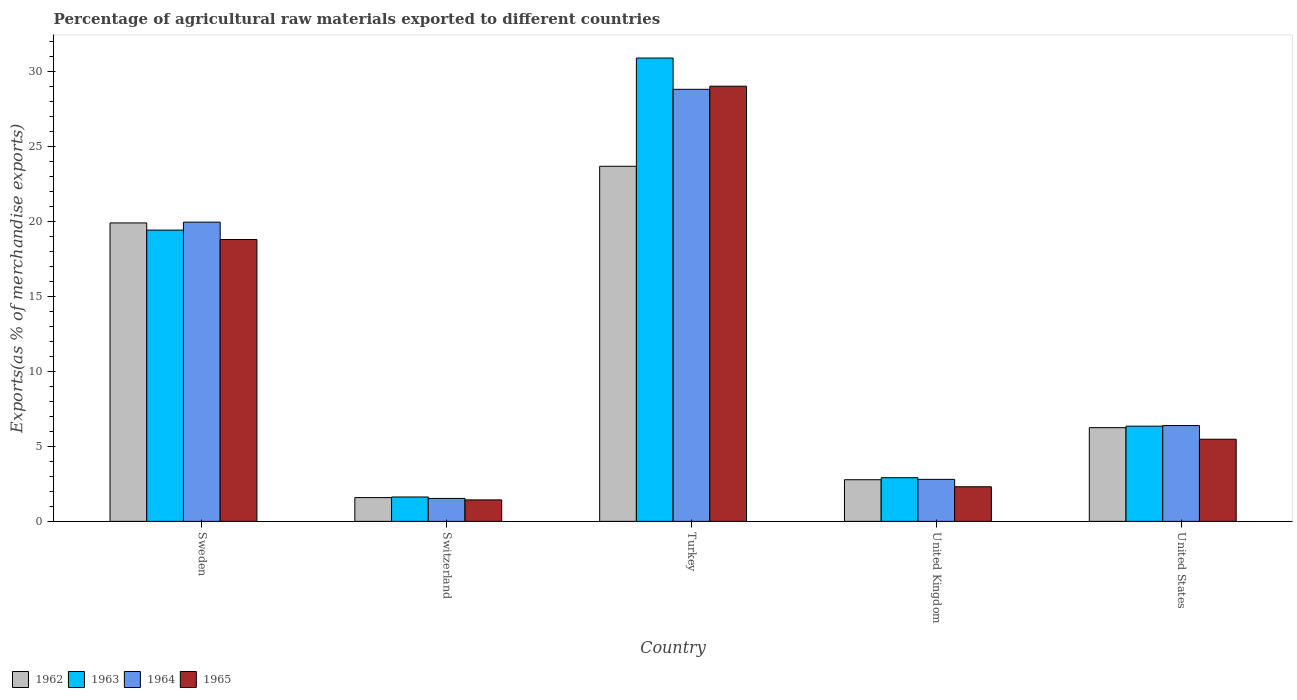How many groups of bars are there?
Provide a short and direct response. 5. Are the number of bars on each tick of the X-axis equal?
Keep it short and to the point. Yes. How many bars are there on the 2nd tick from the left?
Give a very brief answer. 4. How many bars are there on the 3rd tick from the right?
Your response must be concise. 4. In how many cases, is the number of bars for a given country not equal to the number of legend labels?
Give a very brief answer. 0. What is the percentage of exports to different countries in 1963 in United Kingdom?
Keep it short and to the point. 2.91. Across all countries, what is the maximum percentage of exports to different countries in 1964?
Your answer should be very brief. 28.78. Across all countries, what is the minimum percentage of exports to different countries in 1964?
Keep it short and to the point. 1.53. In which country was the percentage of exports to different countries in 1963 maximum?
Your response must be concise. Turkey. In which country was the percentage of exports to different countries in 1962 minimum?
Your answer should be very brief. Switzerland. What is the total percentage of exports to different countries in 1963 in the graph?
Your answer should be very brief. 61.14. What is the difference between the percentage of exports to different countries in 1965 in Sweden and that in Switzerland?
Offer a terse response. 17.35. What is the difference between the percentage of exports to different countries in 1964 in Sweden and the percentage of exports to different countries in 1965 in Turkey?
Offer a very short reply. -9.06. What is the average percentage of exports to different countries in 1962 per country?
Your answer should be very brief. 10.83. What is the difference between the percentage of exports to different countries of/in 1963 and percentage of exports to different countries of/in 1964 in Switzerland?
Your answer should be very brief. 0.1. What is the ratio of the percentage of exports to different countries in 1965 in United Kingdom to that in United States?
Your answer should be compact. 0.42. Is the percentage of exports to different countries in 1964 in Sweden less than that in Switzerland?
Make the answer very short. No. What is the difference between the highest and the second highest percentage of exports to different countries in 1962?
Ensure brevity in your answer.  13.64. What is the difference between the highest and the lowest percentage of exports to different countries in 1964?
Provide a short and direct response. 27.25. Is the sum of the percentage of exports to different countries in 1965 in Turkey and United Kingdom greater than the maximum percentage of exports to different countries in 1962 across all countries?
Give a very brief answer. Yes. What does the 4th bar from the left in United States represents?
Make the answer very short. 1965. Are all the bars in the graph horizontal?
Your response must be concise. No. What is the difference between two consecutive major ticks on the Y-axis?
Provide a short and direct response. 5. Are the values on the major ticks of Y-axis written in scientific E-notation?
Make the answer very short. No. Does the graph contain grids?
Give a very brief answer. No. Where does the legend appear in the graph?
Make the answer very short. Bottom left. What is the title of the graph?
Your answer should be very brief. Percentage of agricultural raw materials exported to different countries. Does "2014" appear as one of the legend labels in the graph?
Keep it short and to the point. No. What is the label or title of the Y-axis?
Give a very brief answer. Exports(as % of merchandise exports). What is the Exports(as % of merchandise exports) in 1962 in Sweden?
Give a very brief answer. 19.88. What is the Exports(as % of merchandise exports) in 1963 in Sweden?
Give a very brief answer. 19.4. What is the Exports(as % of merchandise exports) of 1964 in Sweden?
Your answer should be compact. 19.93. What is the Exports(as % of merchandise exports) of 1965 in Sweden?
Your answer should be compact. 18.78. What is the Exports(as % of merchandise exports) of 1962 in Switzerland?
Ensure brevity in your answer.  1.58. What is the Exports(as % of merchandise exports) in 1963 in Switzerland?
Ensure brevity in your answer.  1.62. What is the Exports(as % of merchandise exports) in 1964 in Switzerland?
Make the answer very short. 1.53. What is the Exports(as % of merchandise exports) in 1965 in Switzerland?
Keep it short and to the point. 1.43. What is the Exports(as % of merchandise exports) of 1962 in Turkey?
Give a very brief answer. 23.65. What is the Exports(as % of merchandise exports) in 1963 in Turkey?
Your answer should be very brief. 30.86. What is the Exports(as % of merchandise exports) of 1964 in Turkey?
Your answer should be compact. 28.78. What is the Exports(as % of merchandise exports) in 1965 in Turkey?
Your response must be concise. 28.99. What is the Exports(as % of merchandise exports) of 1962 in United Kingdom?
Your answer should be compact. 2.77. What is the Exports(as % of merchandise exports) in 1963 in United Kingdom?
Your answer should be compact. 2.91. What is the Exports(as % of merchandise exports) of 1964 in United Kingdom?
Your answer should be very brief. 2.8. What is the Exports(as % of merchandise exports) of 1965 in United Kingdom?
Provide a succinct answer. 2.3. What is the Exports(as % of merchandise exports) in 1962 in United States?
Keep it short and to the point. 6.24. What is the Exports(as % of merchandise exports) in 1963 in United States?
Your answer should be compact. 6.34. What is the Exports(as % of merchandise exports) in 1964 in United States?
Provide a short and direct response. 6.38. What is the Exports(as % of merchandise exports) in 1965 in United States?
Provide a succinct answer. 5.47. Across all countries, what is the maximum Exports(as % of merchandise exports) in 1962?
Make the answer very short. 23.65. Across all countries, what is the maximum Exports(as % of merchandise exports) of 1963?
Keep it short and to the point. 30.86. Across all countries, what is the maximum Exports(as % of merchandise exports) in 1964?
Provide a succinct answer. 28.78. Across all countries, what is the maximum Exports(as % of merchandise exports) in 1965?
Offer a very short reply. 28.99. Across all countries, what is the minimum Exports(as % of merchandise exports) of 1962?
Your response must be concise. 1.58. Across all countries, what is the minimum Exports(as % of merchandise exports) in 1963?
Keep it short and to the point. 1.62. Across all countries, what is the minimum Exports(as % of merchandise exports) of 1964?
Keep it short and to the point. 1.53. Across all countries, what is the minimum Exports(as % of merchandise exports) of 1965?
Ensure brevity in your answer.  1.43. What is the total Exports(as % of merchandise exports) in 1962 in the graph?
Provide a succinct answer. 54.14. What is the total Exports(as % of merchandise exports) in 1963 in the graph?
Give a very brief answer. 61.14. What is the total Exports(as % of merchandise exports) of 1964 in the graph?
Offer a very short reply. 59.42. What is the total Exports(as % of merchandise exports) in 1965 in the graph?
Provide a succinct answer. 56.97. What is the difference between the Exports(as % of merchandise exports) of 1962 in Sweden and that in Switzerland?
Offer a terse response. 18.3. What is the difference between the Exports(as % of merchandise exports) of 1963 in Sweden and that in Switzerland?
Give a very brief answer. 17.78. What is the difference between the Exports(as % of merchandise exports) in 1964 in Sweden and that in Switzerland?
Offer a very short reply. 18.4. What is the difference between the Exports(as % of merchandise exports) of 1965 in Sweden and that in Switzerland?
Make the answer very short. 17.35. What is the difference between the Exports(as % of merchandise exports) of 1962 in Sweden and that in Turkey?
Your answer should be very brief. -3.77. What is the difference between the Exports(as % of merchandise exports) of 1963 in Sweden and that in Turkey?
Provide a succinct answer. -11.46. What is the difference between the Exports(as % of merchandise exports) of 1964 in Sweden and that in Turkey?
Provide a succinct answer. -8.85. What is the difference between the Exports(as % of merchandise exports) in 1965 in Sweden and that in Turkey?
Make the answer very short. -10.21. What is the difference between the Exports(as % of merchandise exports) in 1962 in Sweden and that in United Kingdom?
Your response must be concise. 17.11. What is the difference between the Exports(as % of merchandise exports) in 1963 in Sweden and that in United Kingdom?
Ensure brevity in your answer.  16.49. What is the difference between the Exports(as % of merchandise exports) of 1964 in Sweden and that in United Kingdom?
Give a very brief answer. 17.13. What is the difference between the Exports(as % of merchandise exports) in 1965 in Sweden and that in United Kingdom?
Provide a short and direct response. 16.47. What is the difference between the Exports(as % of merchandise exports) of 1962 in Sweden and that in United States?
Provide a short and direct response. 13.64. What is the difference between the Exports(as % of merchandise exports) in 1963 in Sweden and that in United States?
Provide a short and direct response. 13.06. What is the difference between the Exports(as % of merchandise exports) in 1964 in Sweden and that in United States?
Your answer should be compact. 13.55. What is the difference between the Exports(as % of merchandise exports) of 1965 in Sweden and that in United States?
Offer a very short reply. 13.3. What is the difference between the Exports(as % of merchandise exports) of 1962 in Switzerland and that in Turkey?
Offer a terse response. -22.07. What is the difference between the Exports(as % of merchandise exports) of 1963 in Switzerland and that in Turkey?
Keep it short and to the point. -29.24. What is the difference between the Exports(as % of merchandise exports) of 1964 in Switzerland and that in Turkey?
Provide a succinct answer. -27.25. What is the difference between the Exports(as % of merchandise exports) in 1965 in Switzerland and that in Turkey?
Your answer should be compact. -27.56. What is the difference between the Exports(as % of merchandise exports) in 1962 in Switzerland and that in United Kingdom?
Provide a short and direct response. -1.19. What is the difference between the Exports(as % of merchandise exports) in 1963 in Switzerland and that in United Kingdom?
Offer a very short reply. -1.28. What is the difference between the Exports(as % of merchandise exports) of 1964 in Switzerland and that in United Kingdom?
Your answer should be very brief. -1.27. What is the difference between the Exports(as % of merchandise exports) in 1965 in Switzerland and that in United Kingdom?
Offer a very short reply. -0.87. What is the difference between the Exports(as % of merchandise exports) of 1962 in Switzerland and that in United States?
Ensure brevity in your answer.  -4.66. What is the difference between the Exports(as % of merchandise exports) in 1963 in Switzerland and that in United States?
Provide a succinct answer. -4.72. What is the difference between the Exports(as % of merchandise exports) in 1964 in Switzerland and that in United States?
Offer a very short reply. -4.85. What is the difference between the Exports(as % of merchandise exports) in 1965 in Switzerland and that in United States?
Provide a short and direct response. -4.04. What is the difference between the Exports(as % of merchandise exports) of 1962 in Turkey and that in United Kingdom?
Offer a terse response. 20.88. What is the difference between the Exports(as % of merchandise exports) in 1963 in Turkey and that in United Kingdom?
Offer a very short reply. 27.96. What is the difference between the Exports(as % of merchandise exports) in 1964 in Turkey and that in United Kingdom?
Make the answer very short. 25.98. What is the difference between the Exports(as % of merchandise exports) of 1965 in Turkey and that in United Kingdom?
Offer a very short reply. 26.68. What is the difference between the Exports(as % of merchandise exports) of 1962 in Turkey and that in United States?
Offer a very short reply. 17.41. What is the difference between the Exports(as % of merchandise exports) of 1963 in Turkey and that in United States?
Offer a terse response. 24.52. What is the difference between the Exports(as % of merchandise exports) in 1964 in Turkey and that in United States?
Offer a terse response. 22.4. What is the difference between the Exports(as % of merchandise exports) in 1965 in Turkey and that in United States?
Your answer should be compact. 23.52. What is the difference between the Exports(as % of merchandise exports) in 1962 in United Kingdom and that in United States?
Provide a short and direct response. -3.47. What is the difference between the Exports(as % of merchandise exports) of 1963 in United Kingdom and that in United States?
Offer a very short reply. -3.43. What is the difference between the Exports(as % of merchandise exports) of 1964 in United Kingdom and that in United States?
Provide a short and direct response. -3.58. What is the difference between the Exports(as % of merchandise exports) in 1965 in United Kingdom and that in United States?
Your answer should be very brief. -3.17. What is the difference between the Exports(as % of merchandise exports) in 1962 in Sweden and the Exports(as % of merchandise exports) in 1963 in Switzerland?
Provide a succinct answer. 18.26. What is the difference between the Exports(as % of merchandise exports) in 1962 in Sweden and the Exports(as % of merchandise exports) in 1964 in Switzerland?
Your response must be concise. 18.35. What is the difference between the Exports(as % of merchandise exports) of 1962 in Sweden and the Exports(as % of merchandise exports) of 1965 in Switzerland?
Make the answer very short. 18.45. What is the difference between the Exports(as % of merchandise exports) in 1963 in Sweden and the Exports(as % of merchandise exports) in 1964 in Switzerland?
Offer a terse response. 17.87. What is the difference between the Exports(as % of merchandise exports) in 1963 in Sweden and the Exports(as % of merchandise exports) in 1965 in Switzerland?
Your response must be concise. 17.97. What is the difference between the Exports(as % of merchandise exports) in 1964 in Sweden and the Exports(as % of merchandise exports) in 1965 in Switzerland?
Keep it short and to the point. 18.5. What is the difference between the Exports(as % of merchandise exports) in 1962 in Sweden and the Exports(as % of merchandise exports) in 1963 in Turkey?
Keep it short and to the point. -10.98. What is the difference between the Exports(as % of merchandise exports) of 1962 in Sweden and the Exports(as % of merchandise exports) of 1964 in Turkey?
Offer a very short reply. -8.9. What is the difference between the Exports(as % of merchandise exports) of 1962 in Sweden and the Exports(as % of merchandise exports) of 1965 in Turkey?
Your answer should be compact. -9.11. What is the difference between the Exports(as % of merchandise exports) of 1963 in Sweden and the Exports(as % of merchandise exports) of 1964 in Turkey?
Provide a short and direct response. -9.38. What is the difference between the Exports(as % of merchandise exports) in 1963 in Sweden and the Exports(as % of merchandise exports) in 1965 in Turkey?
Your answer should be compact. -9.59. What is the difference between the Exports(as % of merchandise exports) of 1964 in Sweden and the Exports(as % of merchandise exports) of 1965 in Turkey?
Offer a terse response. -9.06. What is the difference between the Exports(as % of merchandise exports) in 1962 in Sweden and the Exports(as % of merchandise exports) in 1963 in United Kingdom?
Your response must be concise. 16.97. What is the difference between the Exports(as % of merchandise exports) of 1962 in Sweden and the Exports(as % of merchandise exports) of 1964 in United Kingdom?
Offer a very short reply. 17.08. What is the difference between the Exports(as % of merchandise exports) of 1962 in Sweden and the Exports(as % of merchandise exports) of 1965 in United Kingdom?
Your answer should be very brief. 17.58. What is the difference between the Exports(as % of merchandise exports) of 1963 in Sweden and the Exports(as % of merchandise exports) of 1964 in United Kingdom?
Make the answer very short. 16.6. What is the difference between the Exports(as % of merchandise exports) of 1963 in Sweden and the Exports(as % of merchandise exports) of 1965 in United Kingdom?
Make the answer very short. 17.1. What is the difference between the Exports(as % of merchandise exports) of 1964 in Sweden and the Exports(as % of merchandise exports) of 1965 in United Kingdom?
Offer a terse response. 17.63. What is the difference between the Exports(as % of merchandise exports) in 1962 in Sweden and the Exports(as % of merchandise exports) in 1963 in United States?
Provide a short and direct response. 13.54. What is the difference between the Exports(as % of merchandise exports) of 1962 in Sweden and the Exports(as % of merchandise exports) of 1964 in United States?
Your answer should be very brief. 13.5. What is the difference between the Exports(as % of merchandise exports) of 1962 in Sweden and the Exports(as % of merchandise exports) of 1965 in United States?
Provide a succinct answer. 14.41. What is the difference between the Exports(as % of merchandise exports) of 1963 in Sweden and the Exports(as % of merchandise exports) of 1964 in United States?
Give a very brief answer. 13.02. What is the difference between the Exports(as % of merchandise exports) in 1963 in Sweden and the Exports(as % of merchandise exports) in 1965 in United States?
Keep it short and to the point. 13.93. What is the difference between the Exports(as % of merchandise exports) in 1964 in Sweden and the Exports(as % of merchandise exports) in 1965 in United States?
Your answer should be compact. 14.46. What is the difference between the Exports(as % of merchandise exports) in 1962 in Switzerland and the Exports(as % of merchandise exports) in 1963 in Turkey?
Make the answer very short. -29.28. What is the difference between the Exports(as % of merchandise exports) of 1962 in Switzerland and the Exports(as % of merchandise exports) of 1964 in Turkey?
Ensure brevity in your answer.  -27.2. What is the difference between the Exports(as % of merchandise exports) in 1962 in Switzerland and the Exports(as % of merchandise exports) in 1965 in Turkey?
Keep it short and to the point. -27.4. What is the difference between the Exports(as % of merchandise exports) in 1963 in Switzerland and the Exports(as % of merchandise exports) in 1964 in Turkey?
Offer a terse response. -27.16. What is the difference between the Exports(as % of merchandise exports) of 1963 in Switzerland and the Exports(as % of merchandise exports) of 1965 in Turkey?
Ensure brevity in your answer.  -27.36. What is the difference between the Exports(as % of merchandise exports) in 1964 in Switzerland and the Exports(as % of merchandise exports) in 1965 in Turkey?
Ensure brevity in your answer.  -27.46. What is the difference between the Exports(as % of merchandise exports) of 1962 in Switzerland and the Exports(as % of merchandise exports) of 1963 in United Kingdom?
Provide a succinct answer. -1.32. What is the difference between the Exports(as % of merchandise exports) in 1962 in Switzerland and the Exports(as % of merchandise exports) in 1964 in United Kingdom?
Your answer should be very brief. -1.21. What is the difference between the Exports(as % of merchandise exports) in 1962 in Switzerland and the Exports(as % of merchandise exports) in 1965 in United Kingdom?
Provide a short and direct response. -0.72. What is the difference between the Exports(as % of merchandise exports) in 1963 in Switzerland and the Exports(as % of merchandise exports) in 1964 in United Kingdom?
Keep it short and to the point. -1.17. What is the difference between the Exports(as % of merchandise exports) in 1963 in Switzerland and the Exports(as % of merchandise exports) in 1965 in United Kingdom?
Offer a terse response. -0.68. What is the difference between the Exports(as % of merchandise exports) in 1964 in Switzerland and the Exports(as % of merchandise exports) in 1965 in United Kingdom?
Provide a succinct answer. -0.78. What is the difference between the Exports(as % of merchandise exports) in 1962 in Switzerland and the Exports(as % of merchandise exports) in 1963 in United States?
Your response must be concise. -4.76. What is the difference between the Exports(as % of merchandise exports) in 1962 in Switzerland and the Exports(as % of merchandise exports) in 1964 in United States?
Give a very brief answer. -4.8. What is the difference between the Exports(as % of merchandise exports) in 1962 in Switzerland and the Exports(as % of merchandise exports) in 1965 in United States?
Offer a very short reply. -3.89. What is the difference between the Exports(as % of merchandise exports) in 1963 in Switzerland and the Exports(as % of merchandise exports) in 1964 in United States?
Ensure brevity in your answer.  -4.76. What is the difference between the Exports(as % of merchandise exports) in 1963 in Switzerland and the Exports(as % of merchandise exports) in 1965 in United States?
Your response must be concise. -3.85. What is the difference between the Exports(as % of merchandise exports) in 1964 in Switzerland and the Exports(as % of merchandise exports) in 1965 in United States?
Make the answer very short. -3.94. What is the difference between the Exports(as % of merchandise exports) in 1962 in Turkey and the Exports(as % of merchandise exports) in 1963 in United Kingdom?
Make the answer very short. 20.75. What is the difference between the Exports(as % of merchandise exports) of 1962 in Turkey and the Exports(as % of merchandise exports) of 1964 in United Kingdom?
Offer a very short reply. 20.86. What is the difference between the Exports(as % of merchandise exports) in 1962 in Turkey and the Exports(as % of merchandise exports) in 1965 in United Kingdom?
Provide a short and direct response. 21.35. What is the difference between the Exports(as % of merchandise exports) of 1963 in Turkey and the Exports(as % of merchandise exports) of 1964 in United Kingdom?
Make the answer very short. 28.07. What is the difference between the Exports(as % of merchandise exports) of 1963 in Turkey and the Exports(as % of merchandise exports) of 1965 in United Kingdom?
Ensure brevity in your answer.  28.56. What is the difference between the Exports(as % of merchandise exports) in 1964 in Turkey and the Exports(as % of merchandise exports) in 1965 in United Kingdom?
Provide a short and direct response. 26.48. What is the difference between the Exports(as % of merchandise exports) in 1962 in Turkey and the Exports(as % of merchandise exports) in 1963 in United States?
Give a very brief answer. 17.31. What is the difference between the Exports(as % of merchandise exports) of 1962 in Turkey and the Exports(as % of merchandise exports) of 1964 in United States?
Your answer should be very brief. 17.27. What is the difference between the Exports(as % of merchandise exports) in 1962 in Turkey and the Exports(as % of merchandise exports) in 1965 in United States?
Offer a terse response. 18.18. What is the difference between the Exports(as % of merchandise exports) in 1963 in Turkey and the Exports(as % of merchandise exports) in 1964 in United States?
Your answer should be very brief. 24.48. What is the difference between the Exports(as % of merchandise exports) in 1963 in Turkey and the Exports(as % of merchandise exports) in 1965 in United States?
Give a very brief answer. 25.39. What is the difference between the Exports(as % of merchandise exports) of 1964 in Turkey and the Exports(as % of merchandise exports) of 1965 in United States?
Offer a terse response. 23.31. What is the difference between the Exports(as % of merchandise exports) in 1962 in United Kingdom and the Exports(as % of merchandise exports) in 1963 in United States?
Offer a very short reply. -3.57. What is the difference between the Exports(as % of merchandise exports) in 1962 in United Kingdom and the Exports(as % of merchandise exports) in 1964 in United States?
Offer a terse response. -3.61. What is the difference between the Exports(as % of merchandise exports) in 1962 in United Kingdom and the Exports(as % of merchandise exports) in 1965 in United States?
Ensure brevity in your answer.  -2.7. What is the difference between the Exports(as % of merchandise exports) of 1963 in United Kingdom and the Exports(as % of merchandise exports) of 1964 in United States?
Make the answer very short. -3.47. What is the difference between the Exports(as % of merchandise exports) of 1963 in United Kingdom and the Exports(as % of merchandise exports) of 1965 in United States?
Your response must be concise. -2.56. What is the difference between the Exports(as % of merchandise exports) of 1964 in United Kingdom and the Exports(as % of merchandise exports) of 1965 in United States?
Your answer should be compact. -2.67. What is the average Exports(as % of merchandise exports) in 1962 per country?
Ensure brevity in your answer.  10.83. What is the average Exports(as % of merchandise exports) of 1963 per country?
Give a very brief answer. 12.23. What is the average Exports(as % of merchandise exports) of 1964 per country?
Your answer should be very brief. 11.88. What is the average Exports(as % of merchandise exports) of 1965 per country?
Keep it short and to the point. 11.39. What is the difference between the Exports(as % of merchandise exports) in 1962 and Exports(as % of merchandise exports) in 1963 in Sweden?
Keep it short and to the point. 0.48. What is the difference between the Exports(as % of merchandise exports) in 1962 and Exports(as % of merchandise exports) in 1964 in Sweden?
Provide a succinct answer. -0.05. What is the difference between the Exports(as % of merchandise exports) of 1962 and Exports(as % of merchandise exports) of 1965 in Sweden?
Ensure brevity in your answer.  1.1. What is the difference between the Exports(as % of merchandise exports) in 1963 and Exports(as % of merchandise exports) in 1964 in Sweden?
Provide a succinct answer. -0.53. What is the difference between the Exports(as % of merchandise exports) of 1963 and Exports(as % of merchandise exports) of 1965 in Sweden?
Ensure brevity in your answer.  0.63. What is the difference between the Exports(as % of merchandise exports) in 1964 and Exports(as % of merchandise exports) in 1965 in Sweden?
Your response must be concise. 1.16. What is the difference between the Exports(as % of merchandise exports) in 1962 and Exports(as % of merchandise exports) in 1963 in Switzerland?
Your answer should be very brief. -0.04. What is the difference between the Exports(as % of merchandise exports) in 1962 and Exports(as % of merchandise exports) in 1964 in Switzerland?
Provide a short and direct response. 0.06. What is the difference between the Exports(as % of merchandise exports) of 1962 and Exports(as % of merchandise exports) of 1965 in Switzerland?
Your answer should be very brief. 0.15. What is the difference between the Exports(as % of merchandise exports) of 1963 and Exports(as % of merchandise exports) of 1964 in Switzerland?
Give a very brief answer. 0.1. What is the difference between the Exports(as % of merchandise exports) in 1963 and Exports(as % of merchandise exports) in 1965 in Switzerland?
Offer a very short reply. 0.19. What is the difference between the Exports(as % of merchandise exports) of 1964 and Exports(as % of merchandise exports) of 1965 in Switzerland?
Your answer should be compact. 0.1. What is the difference between the Exports(as % of merchandise exports) in 1962 and Exports(as % of merchandise exports) in 1963 in Turkey?
Ensure brevity in your answer.  -7.21. What is the difference between the Exports(as % of merchandise exports) of 1962 and Exports(as % of merchandise exports) of 1964 in Turkey?
Your response must be concise. -5.13. What is the difference between the Exports(as % of merchandise exports) of 1962 and Exports(as % of merchandise exports) of 1965 in Turkey?
Your answer should be compact. -5.33. What is the difference between the Exports(as % of merchandise exports) in 1963 and Exports(as % of merchandise exports) in 1964 in Turkey?
Provide a succinct answer. 2.08. What is the difference between the Exports(as % of merchandise exports) in 1963 and Exports(as % of merchandise exports) in 1965 in Turkey?
Provide a succinct answer. 1.88. What is the difference between the Exports(as % of merchandise exports) in 1964 and Exports(as % of merchandise exports) in 1965 in Turkey?
Offer a terse response. -0.21. What is the difference between the Exports(as % of merchandise exports) of 1962 and Exports(as % of merchandise exports) of 1963 in United Kingdom?
Your response must be concise. -0.13. What is the difference between the Exports(as % of merchandise exports) of 1962 and Exports(as % of merchandise exports) of 1964 in United Kingdom?
Provide a short and direct response. -0.02. What is the difference between the Exports(as % of merchandise exports) in 1962 and Exports(as % of merchandise exports) in 1965 in United Kingdom?
Ensure brevity in your answer.  0.47. What is the difference between the Exports(as % of merchandise exports) in 1963 and Exports(as % of merchandise exports) in 1964 in United Kingdom?
Your answer should be compact. 0.11. What is the difference between the Exports(as % of merchandise exports) of 1963 and Exports(as % of merchandise exports) of 1965 in United Kingdom?
Ensure brevity in your answer.  0.6. What is the difference between the Exports(as % of merchandise exports) in 1964 and Exports(as % of merchandise exports) in 1965 in United Kingdom?
Provide a succinct answer. 0.49. What is the difference between the Exports(as % of merchandise exports) of 1962 and Exports(as % of merchandise exports) of 1963 in United States?
Your response must be concise. -0.1. What is the difference between the Exports(as % of merchandise exports) of 1962 and Exports(as % of merchandise exports) of 1964 in United States?
Provide a short and direct response. -0.14. What is the difference between the Exports(as % of merchandise exports) in 1962 and Exports(as % of merchandise exports) in 1965 in United States?
Make the answer very short. 0.77. What is the difference between the Exports(as % of merchandise exports) of 1963 and Exports(as % of merchandise exports) of 1964 in United States?
Your answer should be compact. -0.04. What is the difference between the Exports(as % of merchandise exports) of 1963 and Exports(as % of merchandise exports) of 1965 in United States?
Provide a short and direct response. 0.87. What is the difference between the Exports(as % of merchandise exports) in 1964 and Exports(as % of merchandise exports) in 1965 in United States?
Give a very brief answer. 0.91. What is the ratio of the Exports(as % of merchandise exports) in 1962 in Sweden to that in Switzerland?
Your answer should be very brief. 12.55. What is the ratio of the Exports(as % of merchandise exports) in 1963 in Sweden to that in Switzerland?
Keep it short and to the point. 11.95. What is the ratio of the Exports(as % of merchandise exports) of 1964 in Sweden to that in Switzerland?
Give a very brief answer. 13.04. What is the ratio of the Exports(as % of merchandise exports) of 1965 in Sweden to that in Switzerland?
Your response must be concise. 13.13. What is the ratio of the Exports(as % of merchandise exports) of 1962 in Sweden to that in Turkey?
Make the answer very short. 0.84. What is the ratio of the Exports(as % of merchandise exports) of 1963 in Sweden to that in Turkey?
Your answer should be very brief. 0.63. What is the ratio of the Exports(as % of merchandise exports) in 1964 in Sweden to that in Turkey?
Keep it short and to the point. 0.69. What is the ratio of the Exports(as % of merchandise exports) of 1965 in Sweden to that in Turkey?
Your answer should be compact. 0.65. What is the ratio of the Exports(as % of merchandise exports) in 1962 in Sweden to that in United Kingdom?
Give a very brief answer. 7.17. What is the ratio of the Exports(as % of merchandise exports) in 1963 in Sweden to that in United Kingdom?
Offer a very short reply. 6.67. What is the ratio of the Exports(as % of merchandise exports) of 1964 in Sweden to that in United Kingdom?
Provide a short and direct response. 7.12. What is the ratio of the Exports(as % of merchandise exports) in 1965 in Sweden to that in United Kingdom?
Make the answer very short. 8.15. What is the ratio of the Exports(as % of merchandise exports) of 1962 in Sweden to that in United States?
Your answer should be compact. 3.18. What is the ratio of the Exports(as % of merchandise exports) in 1963 in Sweden to that in United States?
Keep it short and to the point. 3.06. What is the ratio of the Exports(as % of merchandise exports) in 1964 in Sweden to that in United States?
Provide a succinct answer. 3.12. What is the ratio of the Exports(as % of merchandise exports) of 1965 in Sweden to that in United States?
Make the answer very short. 3.43. What is the ratio of the Exports(as % of merchandise exports) of 1962 in Switzerland to that in Turkey?
Offer a terse response. 0.07. What is the ratio of the Exports(as % of merchandise exports) of 1963 in Switzerland to that in Turkey?
Keep it short and to the point. 0.05. What is the ratio of the Exports(as % of merchandise exports) of 1964 in Switzerland to that in Turkey?
Keep it short and to the point. 0.05. What is the ratio of the Exports(as % of merchandise exports) in 1965 in Switzerland to that in Turkey?
Provide a succinct answer. 0.05. What is the ratio of the Exports(as % of merchandise exports) in 1962 in Switzerland to that in United Kingdom?
Your answer should be compact. 0.57. What is the ratio of the Exports(as % of merchandise exports) in 1963 in Switzerland to that in United Kingdom?
Your response must be concise. 0.56. What is the ratio of the Exports(as % of merchandise exports) in 1964 in Switzerland to that in United Kingdom?
Your response must be concise. 0.55. What is the ratio of the Exports(as % of merchandise exports) in 1965 in Switzerland to that in United Kingdom?
Make the answer very short. 0.62. What is the ratio of the Exports(as % of merchandise exports) in 1962 in Switzerland to that in United States?
Provide a succinct answer. 0.25. What is the ratio of the Exports(as % of merchandise exports) in 1963 in Switzerland to that in United States?
Offer a very short reply. 0.26. What is the ratio of the Exports(as % of merchandise exports) in 1964 in Switzerland to that in United States?
Offer a terse response. 0.24. What is the ratio of the Exports(as % of merchandise exports) in 1965 in Switzerland to that in United States?
Provide a succinct answer. 0.26. What is the ratio of the Exports(as % of merchandise exports) in 1962 in Turkey to that in United Kingdom?
Provide a short and direct response. 8.53. What is the ratio of the Exports(as % of merchandise exports) of 1963 in Turkey to that in United Kingdom?
Offer a terse response. 10.61. What is the ratio of the Exports(as % of merchandise exports) of 1964 in Turkey to that in United Kingdom?
Ensure brevity in your answer.  10.28. What is the ratio of the Exports(as % of merchandise exports) of 1965 in Turkey to that in United Kingdom?
Offer a very short reply. 12.58. What is the ratio of the Exports(as % of merchandise exports) of 1962 in Turkey to that in United States?
Ensure brevity in your answer.  3.79. What is the ratio of the Exports(as % of merchandise exports) of 1963 in Turkey to that in United States?
Make the answer very short. 4.87. What is the ratio of the Exports(as % of merchandise exports) in 1964 in Turkey to that in United States?
Ensure brevity in your answer.  4.51. What is the ratio of the Exports(as % of merchandise exports) of 1965 in Turkey to that in United States?
Your response must be concise. 5.3. What is the ratio of the Exports(as % of merchandise exports) in 1962 in United Kingdom to that in United States?
Offer a very short reply. 0.44. What is the ratio of the Exports(as % of merchandise exports) of 1963 in United Kingdom to that in United States?
Give a very brief answer. 0.46. What is the ratio of the Exports(as % of merchandise exports) of 1964 in United Kingdom to that in United States?
Your answer should be compact. 0.44. What is the ratio of the Exports(as % of merchandise exports) in 1965 in United Kingdom to that in United States?
Offer a terse response. 0.42. What is the difference between the highest and the second highest Exports(as % of merchandise exports) in 1962?
Make the answer very short. 3.77. What is the difference between the highest and the second highest Exports(as % of merchandise exports) in 1963?
Offer a very short reply. 11.46. What is the difference between the highest and the second highest Exports(as % of merchandise exports) of 1964?
Provide a short and direct response. 8.85. What is the difference between the highest and the second highest Exports(as % of merchandise exports) in 1965?
Make the answer very short. 10.21. What is the difference between the highest and the lowest Exports(as % of merchandise exports) in 1962?
Offer a very short reply. 22.07. What is the difference between the highest and the lowest Exports(as % of merchandise exports) in 1963?
Your answer should be very brief. 29.24. What is the difference between the highest and the lowest Exports(as % of merchandise exports) in 1964?
Give a very brief answer. 27.25. What is the difference between the highest and the lowest Exports(as % of merchandise exports) of 1965?
Make the answer very short. 27.56. 